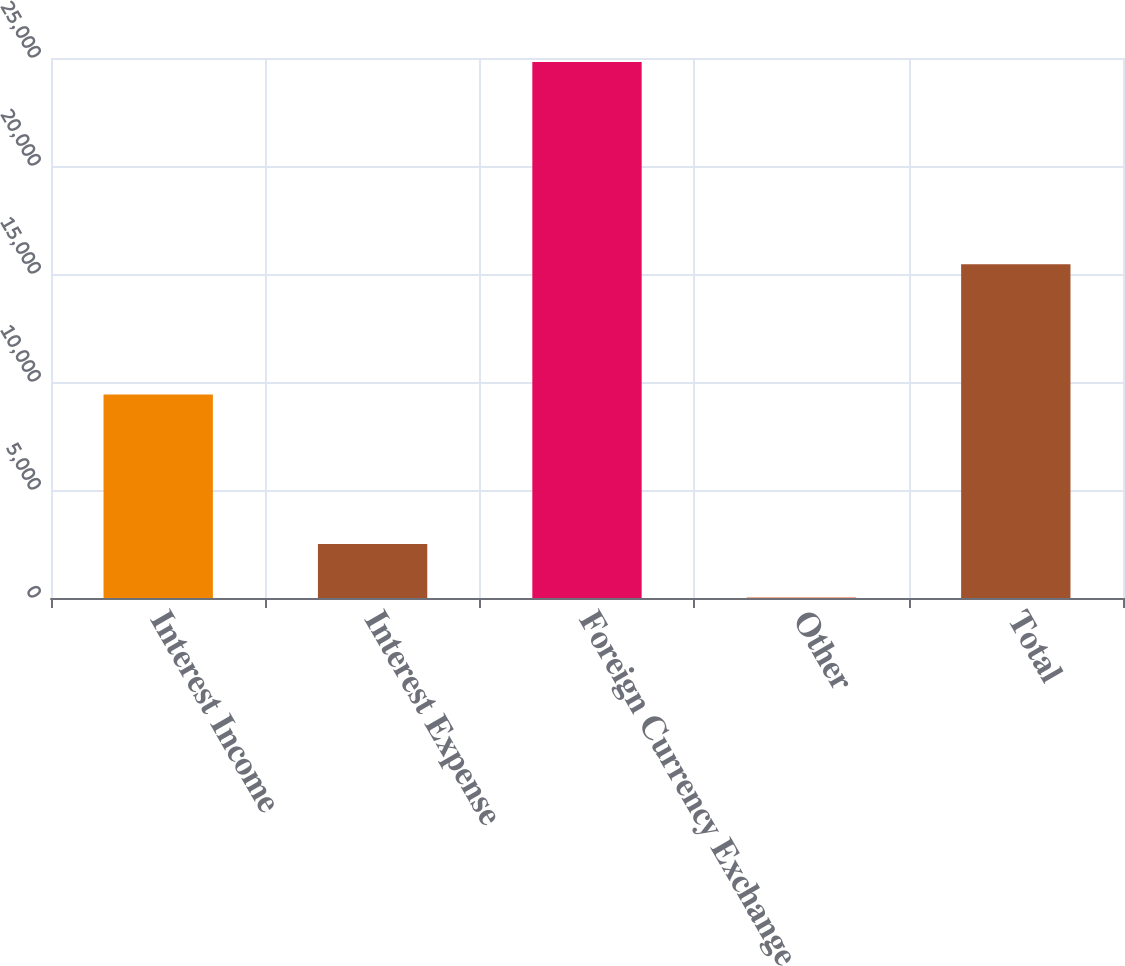Convert chart. <chart><loc_0><loc_0><loc_500><loc_500><bar_chart><fcel>Interest Income<fcel>Interest Expense<fcel>Foreign Currency Exchange<fcel>Other<fcel>Total<nl><fcel>9419<fcel>2499<fcel>24819<fcel>19<fcel>15457<nl></chart> 